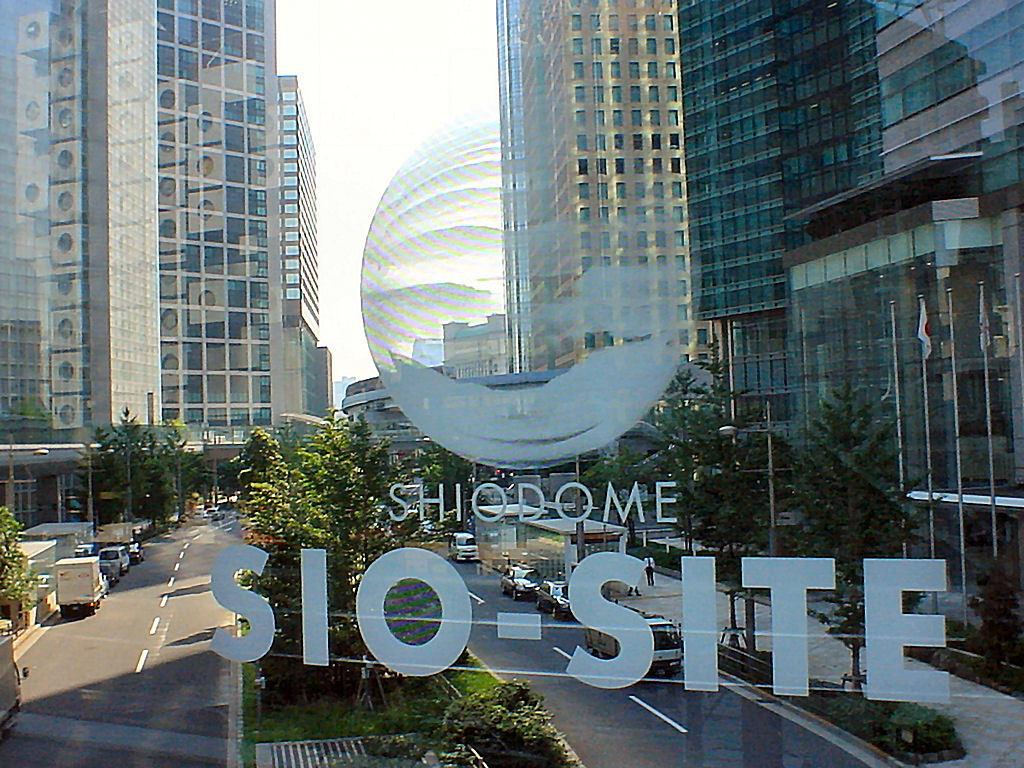What is on the glass in the image? There is a print on a glass in the image. What can be seen through the glass? Trees and vehicles on the roads are visible through the glass. What type of structures are present in the image? There are buildings in the image. What is visible at the top of the image? The sky is visible at the top of the image. What month is being protested in the image? There is no protest or reference to a specific month in the image. How many spiders can be seen crawling on the buildings in the image? There are no spiders visible in the image; it features a print on a glass, trees, vehicles, buildings, and the sky. 